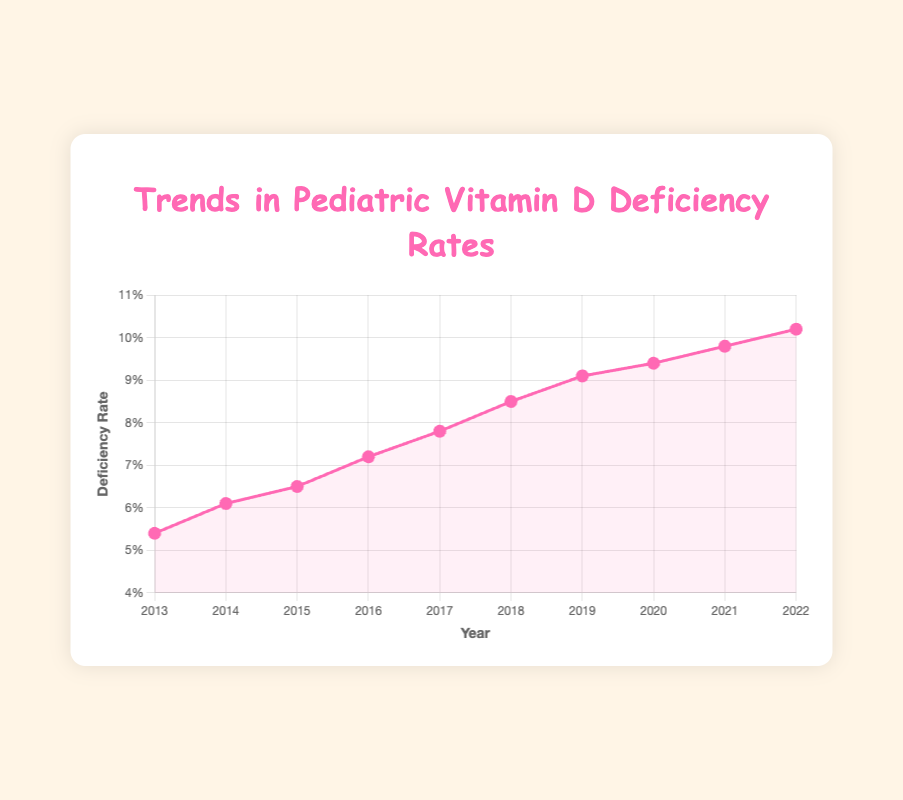What is the rate of pediatric vitamin D deficiency in 2017? Look for the data point on the line chart corresponding to the year 2017. The rate for 2017 is labeled on the y-axis.
Answer: 7.8% How did the pediatric vitamin D deficiency rate change from 2019 to 2020? Identify the rates for the years 2019 (9.1%) and 2020 (9.4%), then calculate the difference (9.4% - 9.1%).
Answer: Increased by 0.3% What is the average rate of pediatric vitamin D deficiency from 2013 to 2015? Add up the rates for 2013 (5.4%), 2014 (6.1%), and 2015 (6.5%), then divide by 3 to find the average ((5.4 + 6.1 + 6.5) / 3).
Answer: 6.0% Which year had the highest pediatric vitamin D deficiency rate? Scan the line chart to identify the highest point, which corresponds to 2022.
Answer: 2022 How much did the pediatric vitamin D deficiency rate increase from 2013 to 2022? Identify the rates for 2013 (5.4%) and 2022 (10.2%), then calculate the difference (10.2% - 5.4%).
Answer: Increased by 4.8% Compare the deficiency rates between 2016 and 2021. Which year had a higher rate? Examine the rates for 2016 (7.2%) and 2021 (9.8%) and determine which is greater.
Answer: 2021 What is the median pediatric vitamin D deficiency rate from 2013 to 2022? List all rates from 2013 to 2022 in ascending order and find the middle value of the dataset (5.4, 6.1, 6.5, 7.2, 7.8, 8.5, 9.1, 9.4, 9.8, 10.2). The median is between the fifth and sixth values.
Answer: 7.8% During which period did the pediatric vitamin D deficiency rate increase most rapidly? Assess the slope between each subsequent year. The largest increase is from 2017 (7.8%) to 2018 (8.5%), calculate the rate of change (8.5% - 7.8%).
Answer: 2017 to 2018 If the trend continues, what would you estimate the deficiency rate to be in 2023? Observe the trend over the past years, particularly the steady increase. Based on the average annual increase from 2021 (9.8%) to 2022 (10.2%), which is 0.4%, add this to the 2022 rate (10.2% + 0.4%).
Answer: Approximately 10.6% What is the total increase in the vitamin D deficiency rate over the decade from 2013 to 2022? Calculate the difference between the first year's rate (2013: 5.4%) and the last year's rate (2022: 10.2%) over the decade. (10.2% - 5.4%).
Answer: 4.8% 